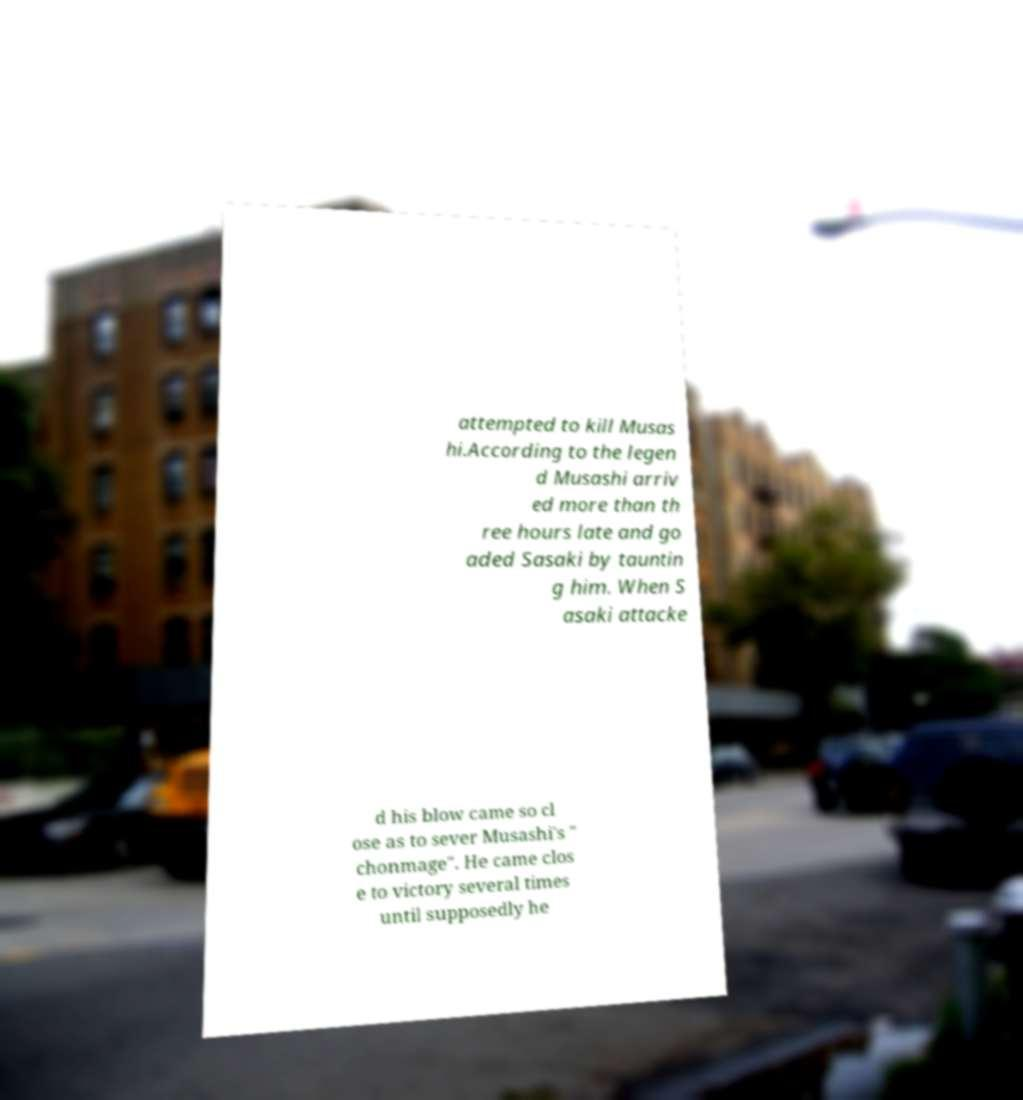Can you read and provide the text displayed in the image?This photo seems to have some interesting text. Can you extract and type it out for me? attempted to kill Musas hi.According to the legen d Musashi arriv ed more than th ree hours late and go aded Sasaki by tauntin g him. When S asaki attacke d his blow came so cl ose as to sever Musashi's " chonmage". He came clos e to victory several times until supposedly he 